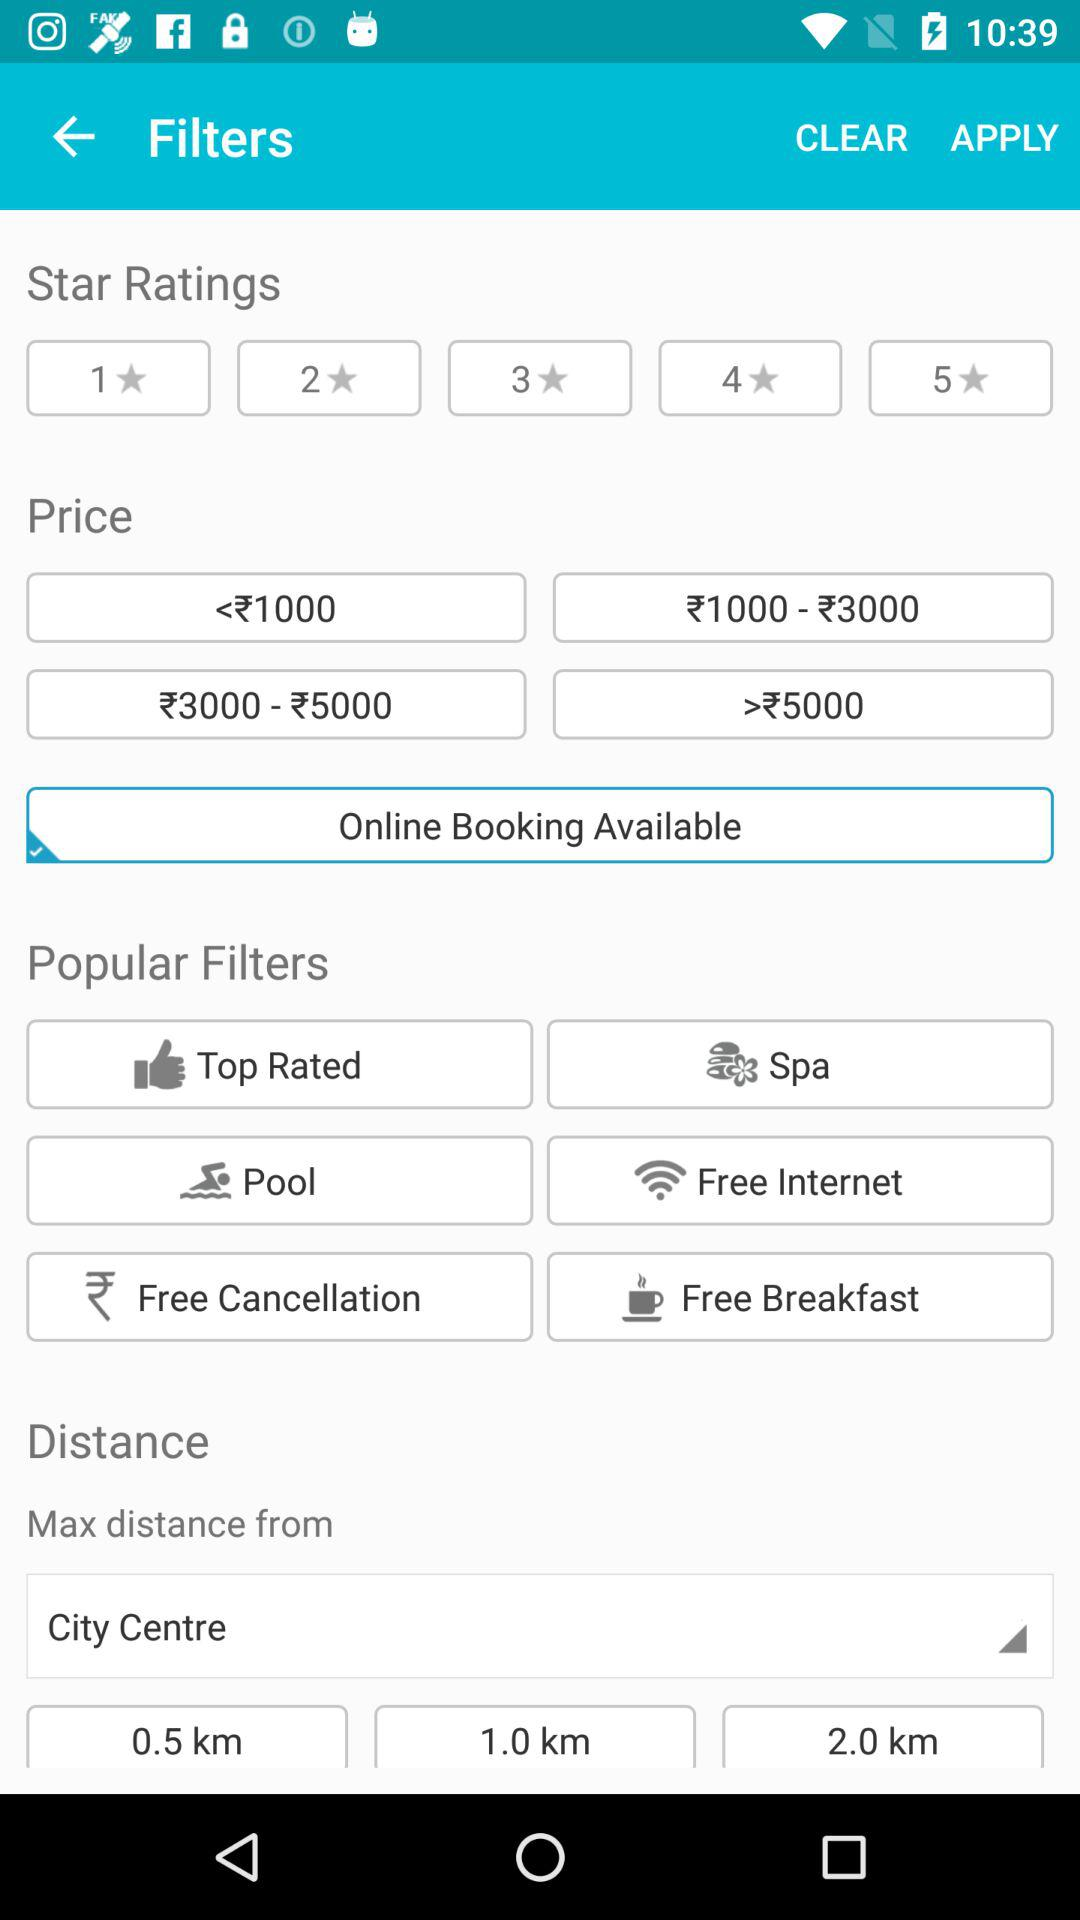How many star ratings are available to filter by?
Answer the question using a single word or phrase. 5 